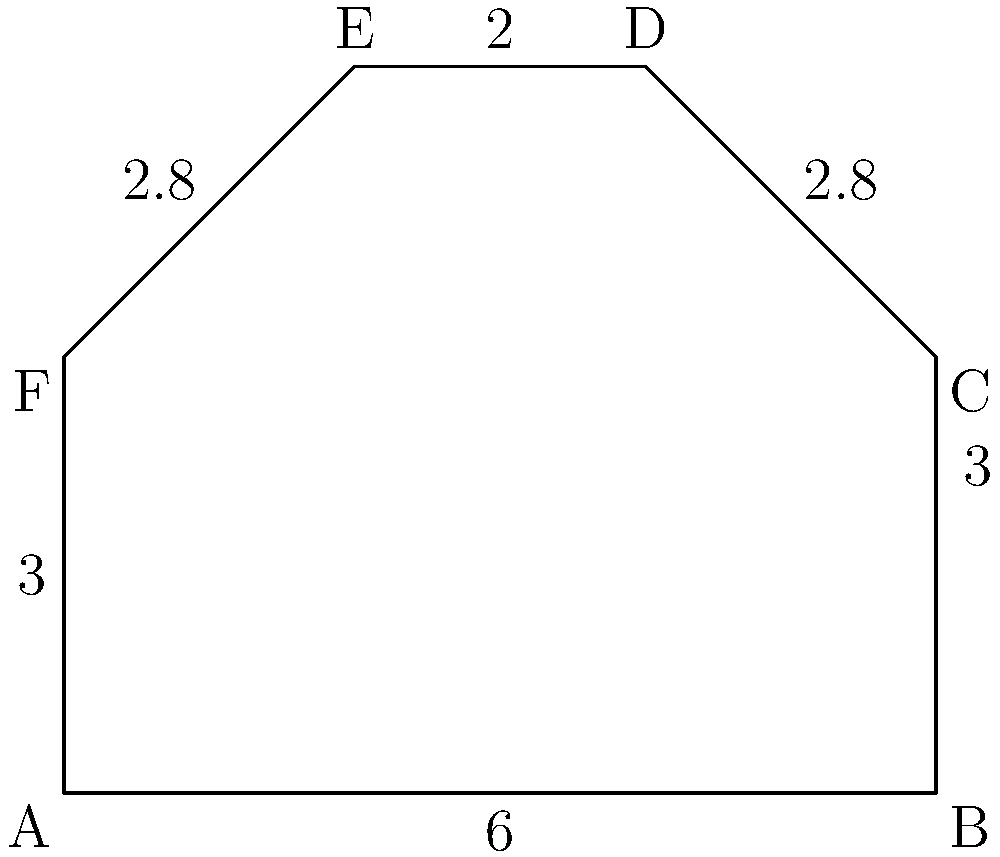A customer wants a unique tattoo design in the shape of an irregular hexagon. The dimensions (in inches) of each side are shown in the diagram. What is the perimeter of this tattoo design? To find the perimeter of the irregular hexagon tattoo design, we need to add up the lengths of all six sides:

1. Side AB: 6 inches
2. Side BC: 3 inches
3. Side CD: 2.8 inches
4. Side DE: 2 inches
5. Side EF: 2.8 inches
6. Side FA: 3 inches

Perimeter = AB + BC + CD + DE + EF + FA
           = 6 + 3 + 2.8 + 2 + 2.8 + 3
           = 19.6 inches

Therefore, the perimeter of the tattoo design is 19.6 inches.
Answer: 19.6 inches 